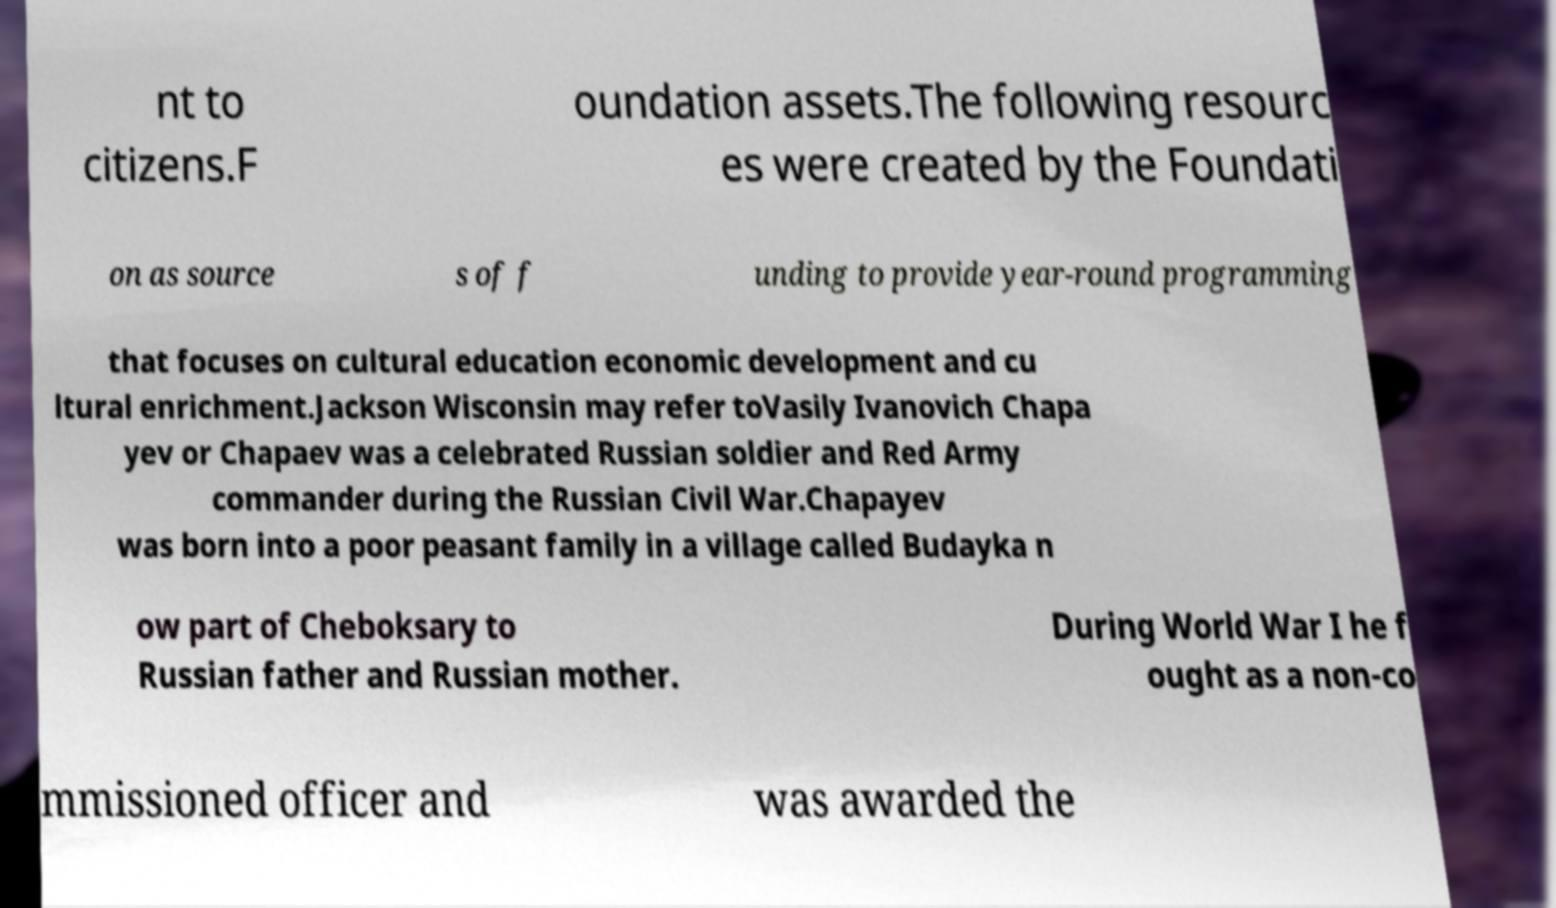For documentation purposes, I need the text within this image transcribed. Could you provide that? nt to citizens.F oundation assets.The following resourc es were created by the Foundati on as source s of f unding to provide year-round programming that focuses on cultural education economic development and cu ltural enrichment.Jackson Wisconsin may refer toVasily Ivanovich Chapa yev or Chapaev was a celebrated Russian soldier and Red Army commander during the Russian Civil War.Chapayev was born into a poor peasant family in a village called Budayka n ow part of Cheboksary to Russian father and Russian mother. During World War I he f ought as a non-co mmissioned officer and was awarded the 